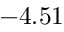<formula> <loc_0><loc_0><loc_500><loc_500>- 4 . 5 1</formula> 